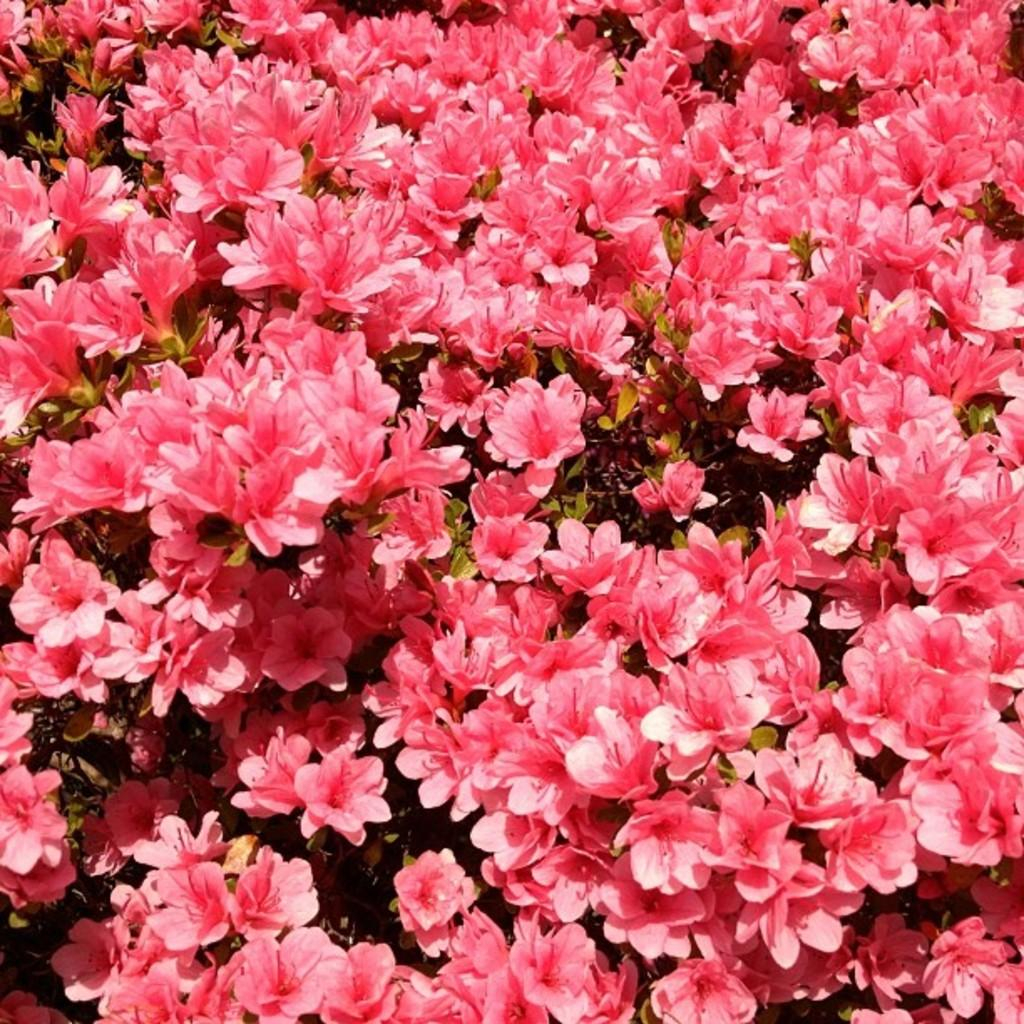What type of flowers are present in the image? There are pink color flowers in the image. Are the flowers attached to any plants? Yes, the flowers are on plants. Can you describe any additional color on the flowers? There is a white color shade on the flowers. How many pencils are visible in the image? There are no pencils present in the image. What type of sheet is covering the flowers in the image? There is no sheet covering the flowers in the image. 